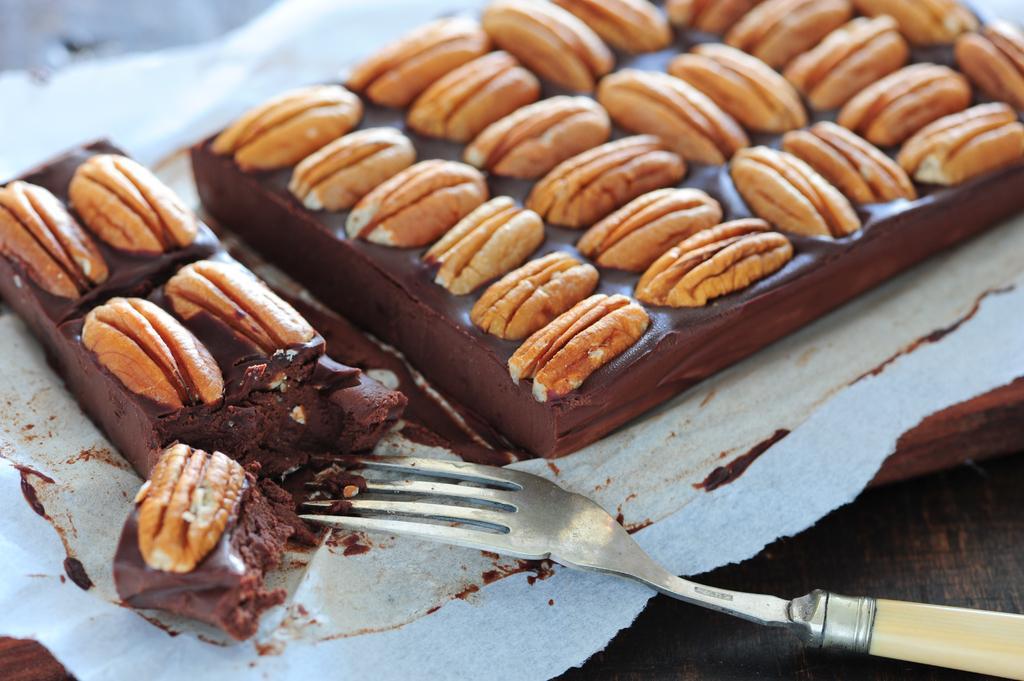In one or two sentences, can you explain what this image depicts? As we can see in the image there are chocolates and a fork. 